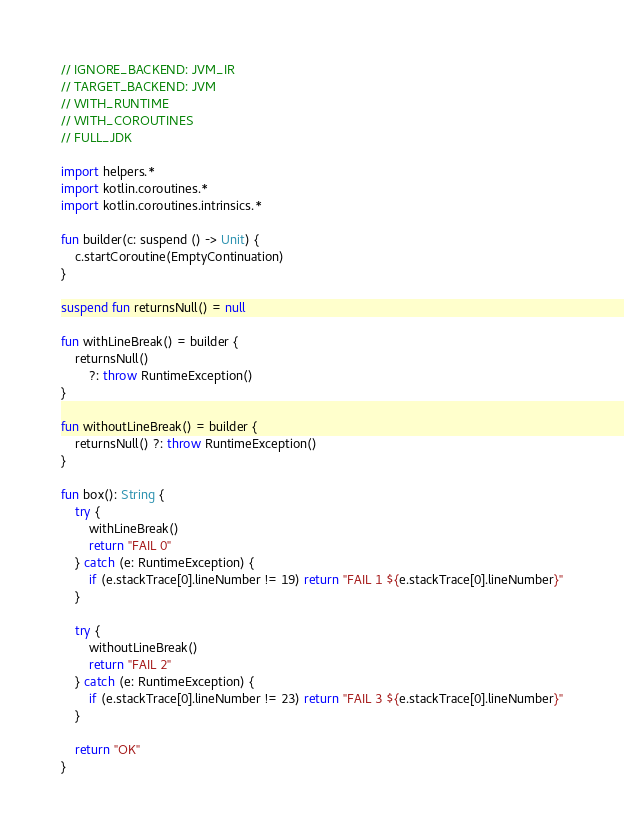Convert code to text. <code><loc_0><loc_0><loc_500><loc_500><_Kotlin_>// IGNORE_BACKEND: JVM_IR
// TARGET_BACKEND: JVM
// WITH_RUNTIME
// WITH_COROUTINES
// FULL_JDK

import helpers.*
import kotlin.coroutines.*
import kotlin.coroutines.intrinsics.*

fun builder(c: suspend () -> Unit) {
    c.startCoroutine(EmptyContinuation)
}

suspend fun returnsNull() = null

fun withLineBreak() = builder {
    returnsNull()
        ?: throw RuntimeException()
}

fun withoutLineBreak() = builder {
    returnsNull() ?: throw RuntimeException()
}

fun box(): String {
    try {
        withLineBreak()
        return "FAIL 0"
    } catch (e: RuntimeException) {
        if (e.stackTrace[0].lineNumber != 19) return "FAIL 1 ${e.stackTrace[0].lineNumber}"
    }

    try {
        withoutLineBreak()
        return "FAIL 2"
    } catch (e: RuntimeException) {
        if (e.stackTrace[0].lineNumber != 23) return "FAIL 3 ${e.stackTrace[0].lineNumber}"
    }

    return "OK"
}</code> 